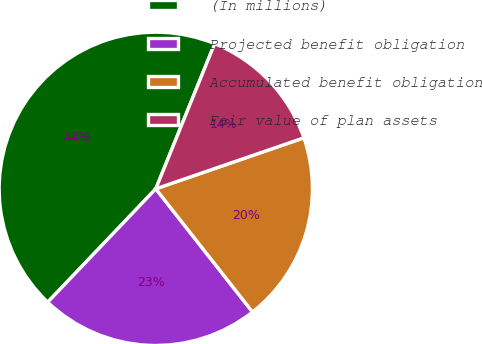Convert chart. <chart><loc_0><loc_0><loc_500><loc_500><pie_chart><fcel>(In millions)<fcel>Projected benefit obligation<fcel>Accumulated benefit obligation<fcel>Fair value of plan assets<nl><fcel>44.01%<fcel>22.72%<fcel>19.68%<fcel>13.59%<nl></chart> 